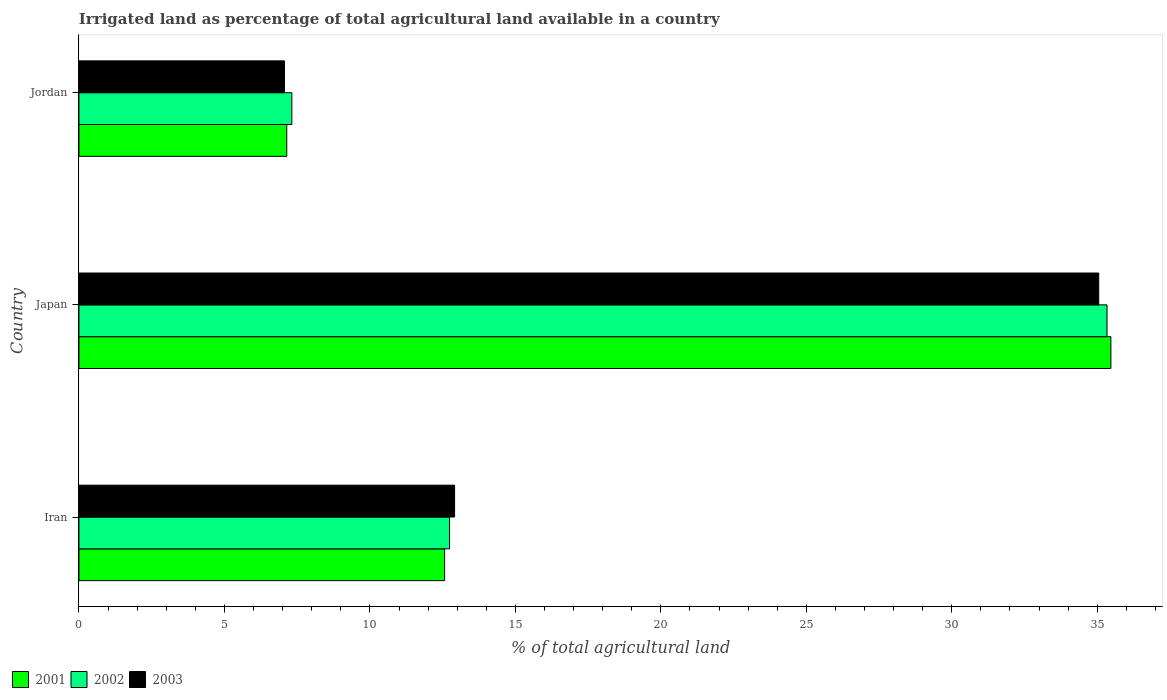How many different coloured bars are there?
Ensure brevity in your answer.  3. Are the number of bars per tick equal to the number of legend labels?
Keep it short and to the point. Yes. Are the number of bars on each tick of the Y-axis equal?
Offer a very short reply. Yes. What is the label of the 3rd group of bars from the top?
Your answer should be very brief. Iran. What is the percentage of irrigated land in 2003 in Jordan?
Ensure brevity in your answer.  7.06. Across all countries, what is the maximum percentage of irrigated land in 2001?
Make the answer very short. 35.47. Across all countries, what is the minimum percentage of irrigated land in 2002?
Provide a short and direct response. 7.32. In which country was the percentage of irrigated land in 2003 minimum?
Your response must be concise. Jordan. What is the total percentage of irrigated land in 2002 in the graph?
Give a very brief answer. 55.39. What is the difference between the percentage of irrigated land in 2003 in Iran and that in Japan?
Your response must be concise. -22.14. What is the difference between the percentage of irrigated land in 2002 in Jordan and the percentage of irrigated land in 2001 in Iran?
Offer a very short reply. -5.25. What is the average percentage of irrigated land in 2003 per country?
Offer a very short reply. 18.34. What is the difference between the percentage of irrigated land in 2003 and percentage of irrigated land in 2001 in Japan?
Give a very brief answer. -0.42. In how many countries, is the percentage of irrigated land in 2003 greater than 10 %?
Make the answer very short. 2. What is the ratio of the percentage of irrigated land in 2003 in Iran to that in Jordan?
Keep it short and to the point. 1.83. Is the percentage of irrigated land in 2001 in Iran less than that in Japan?
Your response must be concise. Yes. Is the difference between the percentage of irrigated land in 2003 in Japan and Jordan greater than the difference between the percentage of irrigated land in 2001 in Japan and Jordan?
Make the answer very short. No. What is the difference between the highest and the second highest percentage of irrigated land in 2003?
Ensure brevity in your answer.  22.14. What is the difference between the highest and the lowest percentage of irrigated land in 2002?
Ensure brevity in your answer.  28.02. In how many countries, is the percentage of irrigated land in 2002 greater than the average percentage of irrigated land in 2002 taken over all countries?
Offer a terse response. 1. Is the sum of the percentage of irrigated land in 2003 in Iran and Jordan greater than the maximum percentage of irrigated land in 2001 across all countries?
Your answer should be very brief. No. What does the 2nd bar from the top in Japan represents?
Provide a succinct answer. 2002. How many bars are there?
Ensure brevity in your answer.  9. How many countries are there in the graph?
Offer a terse response. 3. What is the difference between two consecutive major ticks on the X-axis?
Make the answer very short. 5. Are the values on the major ticks of X-axis written in scientific E-notation?
Keep it short and to the point. No. Does the graph contain any zero values?
Offer a terse response. No. Does the graph contain grids?
Ensure brevity in your answer.  No. How are the legend labels stacked?
Keep it short and to the point. Horizontal. What is the title of the graph?
Your response must be concise. Irrigated land as percentage of total agricultural land available in a country. Does "2011" appear as one of the legend labels in the graph?
Your answer should be compact. No. What is the label or title of the X-axis?
Your response must be concise. % of total agricultural land. What is the label or title of the Y-axis?
Make the answer very short. Country. What is the % of total agricultural land in 2001 in Iran?
Offer a terse response. 12.57. What is the % of total agricultural land in 2002 in Iran?
Give a very brief answer. 12.74. What is the % of total agricultural land of 2003 in Iran?
Your answer should be compact. 12.91. What is the % of total agricultural land in 2001 in Japan?
Offer a very short reply. 35.47. What is the % of total agricultural land of 2002 in Japan?
Make the answer very short. 35.33. What is the % of total agricultural land in 2003 in Japan?
Make the answer very short. 35.05. What is the % of total agricultural land of 2001 in Jordan?
Keep it short and to the point. 7.14. What is the % of total agricultural land in 2002 in Jordan?
Your response must be concise. 7.32. What is the % of total agricultural land of 2003 in Jordan?
Provide a succinct answer. 7.06. Across all countries, what is the maximum % of total agricultural land in 2001?
Ensure brevity in your answer.  35.47. Across all countries, what is the maximum % of total agricultural land of 2002?
Give a very brief answer. 35.33. Across all countries, what is the maximum % of total agricultural land of 2003?
Your answer should be very brief. 35.05. Across all countries, what is the minimum % of total agricultural land in 2001?
Offer a very short reply. 7.14. Across all countries, what is the minimum % of total agricultural land in 2002?
Offer a very short reply. 7.32. Across all countries, what is the minimum % of total agricultural land of 2003?
Give a very brief answer. 7.06. What is the total % of total agricultural land of 2001 in the graph?
Ensure brevity in your answer.  55.18. What is the total % of total agricultural land in 2002 in the graph?
Provide a short and direct response. 55.39. What is the total % of total agricultural land of 2003 in the graph?
Your answer should be compact. 55.03. What is the difference between the % of total agricultural land in 2001 in Iran and that in Japan?
Make the answer very short. -22.9. What is the difference between the % of total agricultural land in 2002 in Iran and that in Japan?
Provide a succinct answer. -22.6. What is the difference between the % of total agricultural land of 2003 in Iran and that in Japan?
Your answer should be very brief. -22.14. What is the difference between the % of total agricultural land in 2001 in Iran and that in Jordan?
Your answer should be compact. 5.42. What is the difference between the % of total agricultural land of 2002 in Iran and that in Jordan?
Provide a succinct answer. 5.42. What is the difference between the % of total agricultural land of 2003 in Iran and that in Jordan?
Ensure brevity in your answer.  5.85. What is the difference between the % of total agricultural land of 2001 in Japan and that in Jordan?
Offer a very short reply. 28.33. What is the difference between the % of total agricultural land in 2002 in Japan and that in Jordan?
Offer a terse response. 28.02. What is the difference between the % of total agricultural land in 2003 in Japan and that in Jordan?
Give a very brief answer. 27.99. What is the difference between the % of total agricultural land of 2001 in Iran and the % of total agricultural land of 2002 in Japan?
Give a very brief answer. -22.77. What is the difference between the % of total agricultural land of 2001 in Iran and the % of total agricultural land of 2003 in Japan?
Your response must be concise. -22.48. What is the difference between the % of total agricultural land of 2002 in Iran and the % of total agricultural land of 2003 in Japan?
Provide a short and direct response. -22.31. What is the difference between the % of total agricultural land of 2001 in Iran and the % of total agricultural land of 2002 in Jordan?
Offer a very short reply. 5.25. What is the difference between the % of total agricultural land in 2001 in Iran and the % of total agricultural land in 2003 in Jordan?
Your answer should be compact. 5.5. What is the difference between the % of total agricultural land in 2002 in Iran and the % of total agricultural land in 2003 in Jordan?
Offer a very short reply. 5.67. What is the difference between the % of total agricultural land in 2001 in Japan and the % of total agricultural land in 2002 in Jordan?
Your answer should be very brief. 28.15. What is the difference between the % of total agricultural land of 2001 in Japan and the % of total agricultural land of 2003 in Jordan?
Your answer should be very brief. 28.4. What is the difference between the % of total agricultural land of 2002 in Japan and the % of total agricultural land of 2003 in Jordan?
Your answer should be very brief. 28.27. What is the average % of total agricultural land in 2001 per country?
Your response must be concise. 18.39. What is the average % of total agricultural land of 2002 per country?
Provide a short and direct response. 18.46. What is the average % of total agricultural land of 2003 per country?
Your response must be concise. 18.34. What is the difference between the % of total agricultural land in 2001 and % of total agricultural land in 2002 in Iran?
Your response must be concise. -0.17. What is the difference between the % of total agricultural land of 2001 and % of total agricultural land of 2003 in Iran?
Give a very brief answer. -0.34. What is the difference between the % of total agricultural land in 2002 and % of total agricultural land in 2003 in Iran?
Your answer should be compact. -0.17. What is the difference between the % of total agricultural land in 2001 and % of total agricultural land in 2002 in Japan?
Ensure brevity in your answer.  0.13. What is the difference between the % of total agricultural land of 2001 and % of total agricultural land of 2003 in Japan?
Your answer should be very brief. 0.42. What is the difference between the % of total agricultural land of 2002 and % of total agricultural land of 2003 in Japan?
Provide a short and direct response. 0.28. What is the difference between the % of total agricultural land of 2001 and % of total agricultural land of 2002 in Jordan?
Provide a short and direct response. -0.17. What is the difference between the % of total agricultural land in 2001 and % of total agricultural land in 2003 in Jordan?
Offer a terse response. 0.08. What is the difference between the % of total agricultural land of 2002 and % of total agricultural land of 2003 in Jordan?
Your response must be concise. 0.25. What is the ratio of the % of total agricultural land of 2001 in Iran to that in Japan?
Keep it short and to the point. 0.35. What is the ratio of the % of total agricultural land of 2002 in Iran to that in Japan?
Your answer should be very brief. 0.36. What is the ratio of the % of total agricultural land in 2003 in Iran to that in Japan?
Your answer should be compact. 0.37. What is the ratio of the % of total agricultural land in 2001 in Iran to that in Jordan?
Make the answer very short. 1.76. What is the ratio of the % of total agricultural land of 2002 in Iran to that in Jordan?
Keep it short and to the point. 1.74. What is the ratio of the % of total agricultural land in 2003 in Iran to that in Jordan?
Keep it short and to the point. 1.83. What is the ratio of the % of total agricultural land in 2001 in Japan to that in Jordan?
Offer a terse response. 4.97. What is the ratio of the % of total agricultural land in 2002 in Japan to that in Jordan?
Ensure brevity in your answer.  4.83. What is the ratio of the % of total agricultural land of 2003 in Japan to that in Jordan?
Your answer should be very brief. 4.96. What is the difference between the highest and the second highest % of total agricultural land in 2001?
Provide a short and direct response. 22.9. What is the difference between the highest and the second highest % of total agricultural land in 2002?
Your answer should be compact. 22.6. What is the difference between the highest and the second highest % of total agricultural land in 2003?
Give a very brief answer. 22.14. What is the difference between the highest and the lowest % of total agricultural land in 2001?
Provide a succinct answer. 28.33. What is the difference between the highest and the lowest % of total agricultural land of 2002?
Your answer should be very brief. 28.02. What is the difference between the highest and the lowest % of total agricultural land in 2003?
Keep it short and to the point. 27.99. 